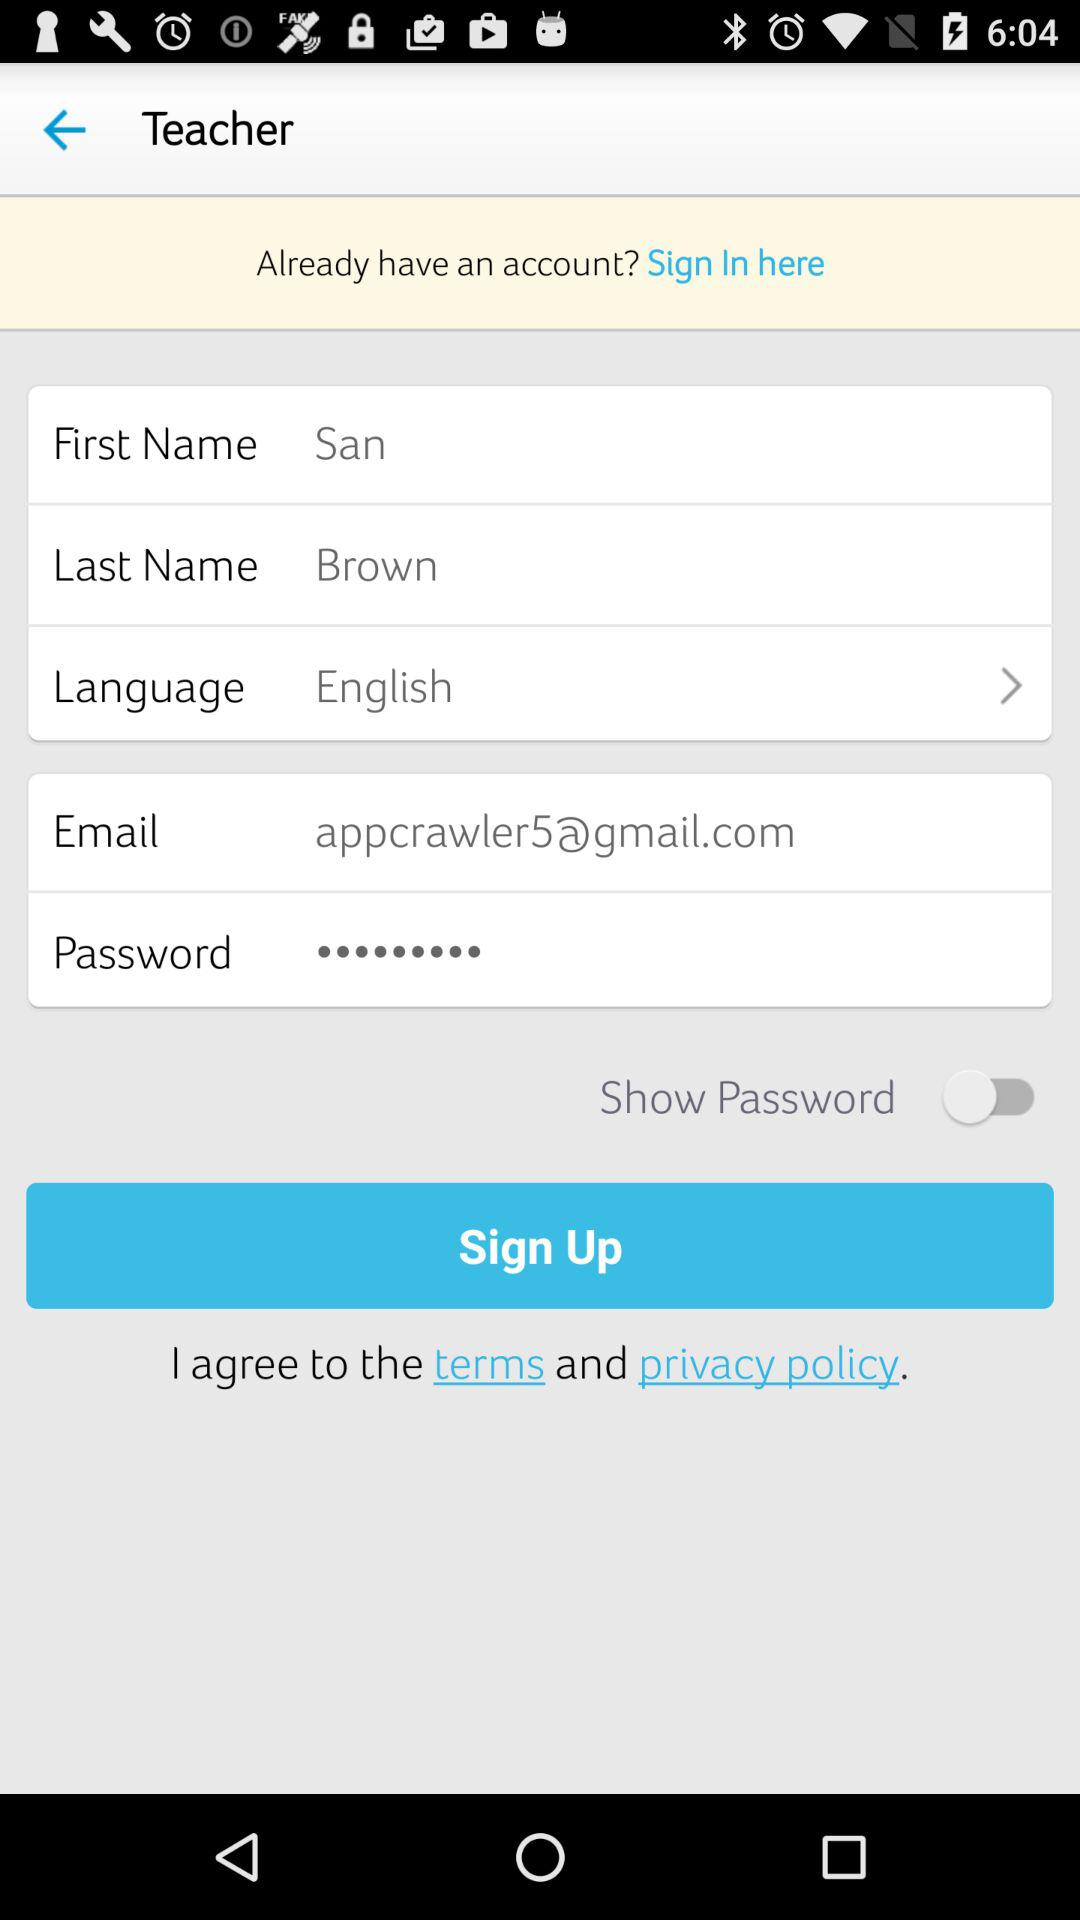What is the status of "Show Password"? The status is "off". 